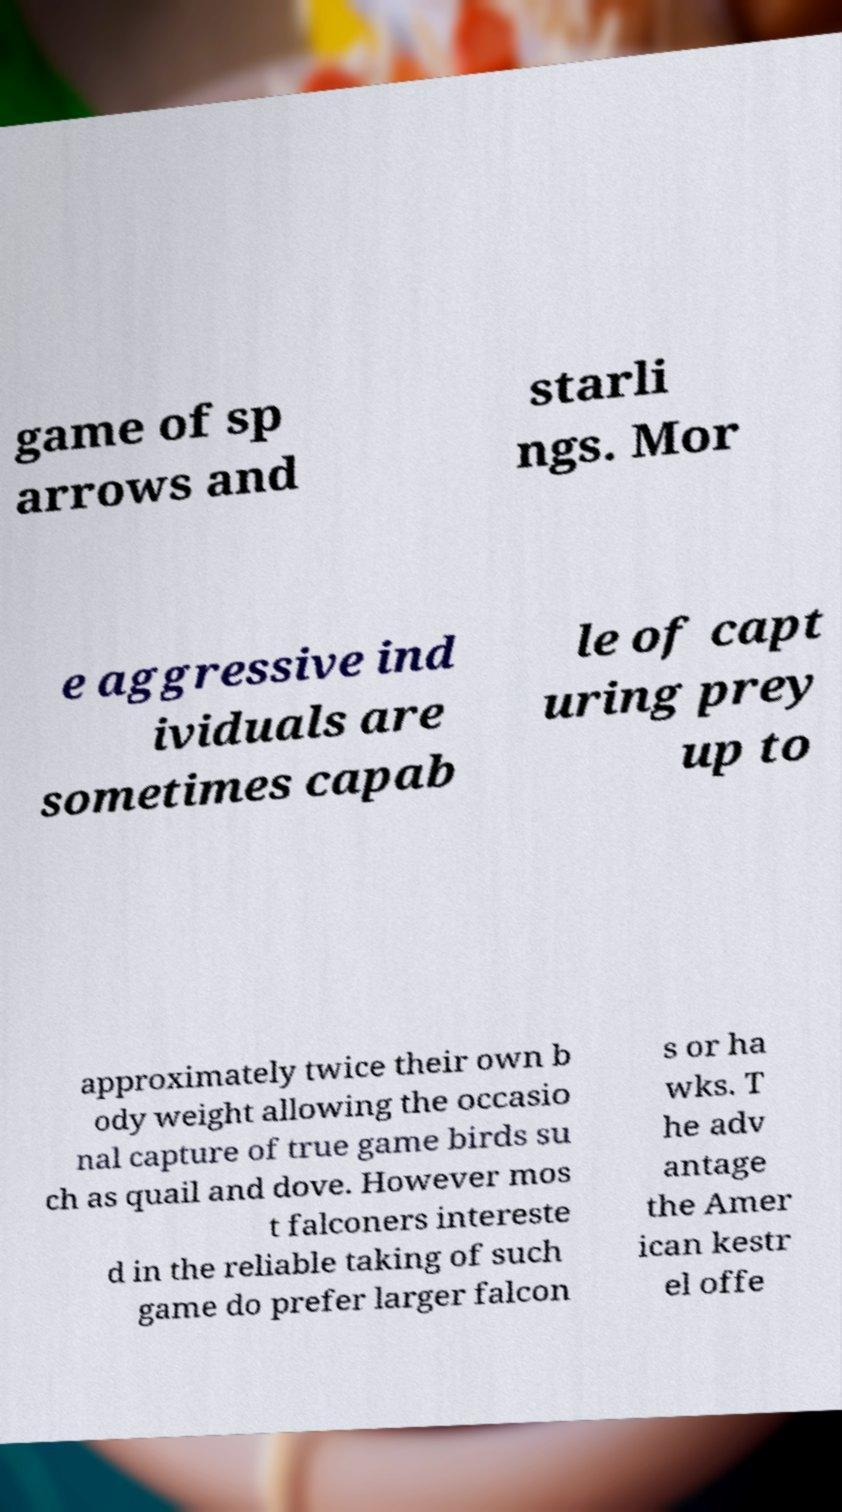I need the written content from this picture converted into text. Can you do that? game of sp arrows and starli ngs. Mor e aggressive ind ividuals are sometimes capab le of capt uring prey up to approximately twice their own b ody weight allowing the occasio nal capture of true game birds su ch as quail and dove. However mos t falconers intereste d in the reliable taking of such game do prefer larger falcon s or ha wks. T he adv antage the Amer ican kestr el offe 